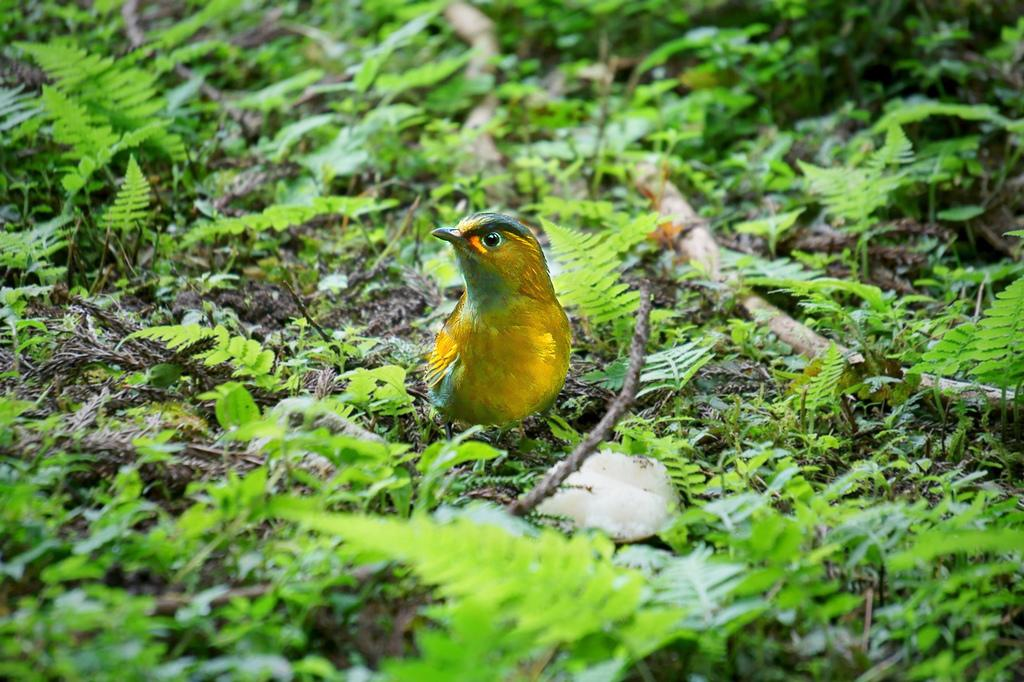What type of animal can be seen in the image? There is a bird in the image. Where is the bird located? The bird is on the ground in the image. What else can be seen on the ground in the image? There are plants on the ground in the image. What flavor of cake is being served at the bird's birthday party in the image? There is no cake or birthday party present in the image; it features a bird on the ground with plants. 